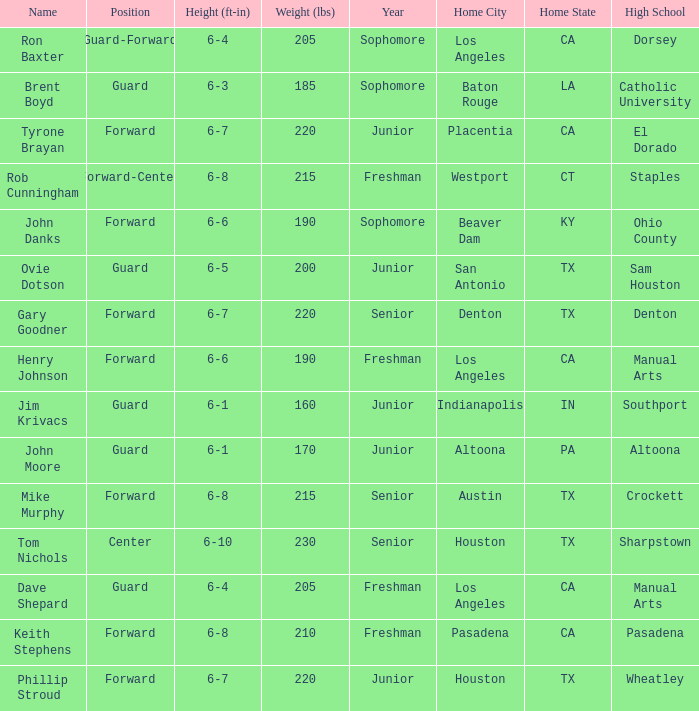What is the Home Town with a Name with rob cunningham? Westport, CT. 